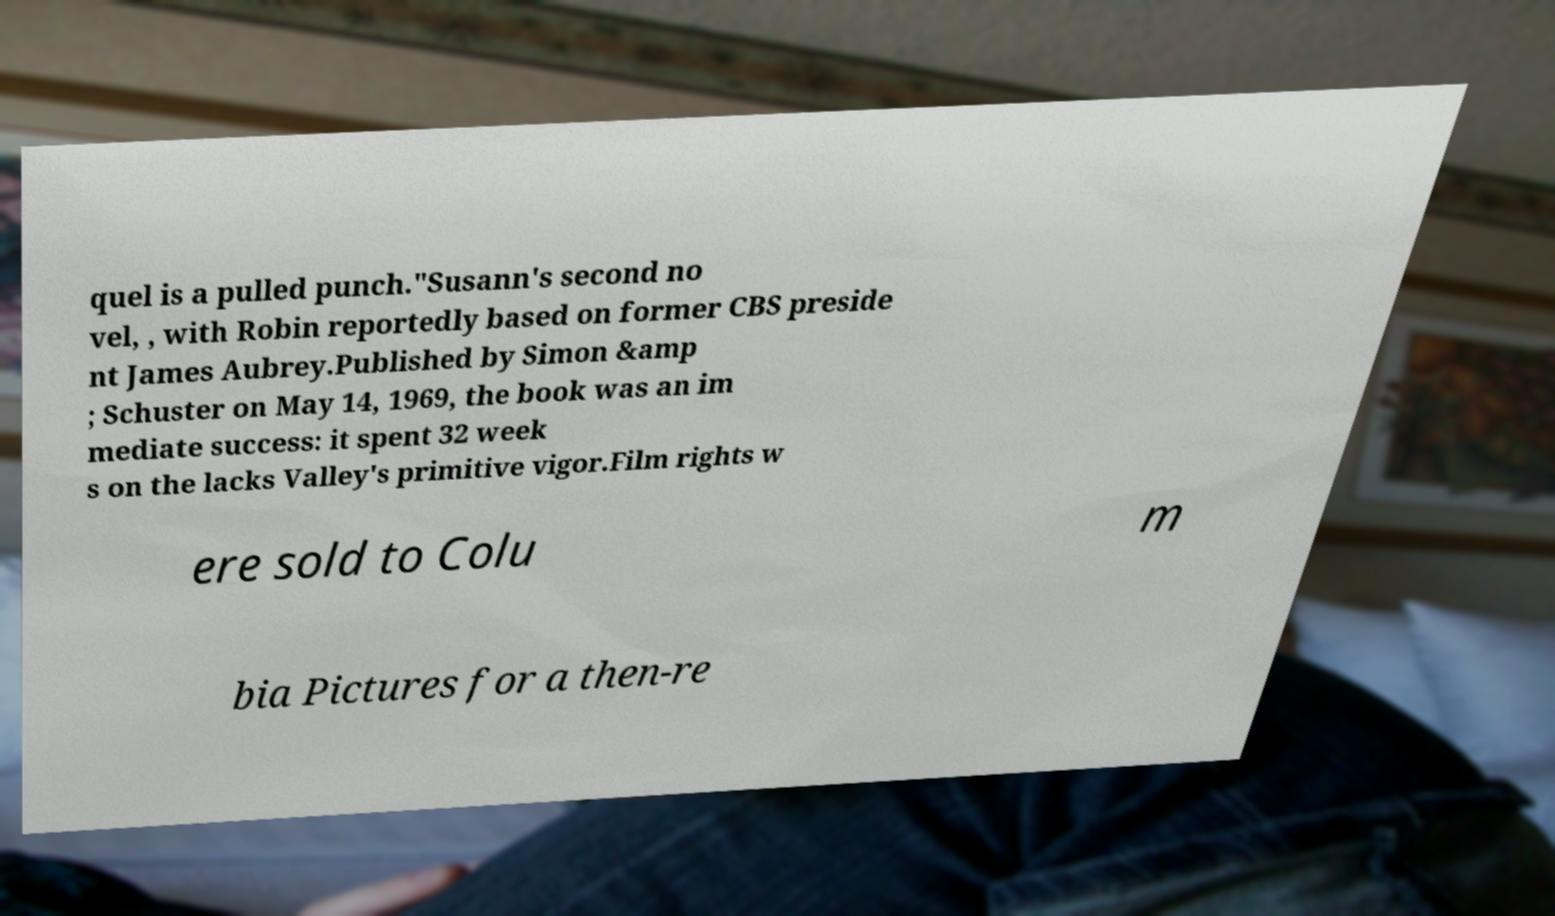Could you assist in decoding the text presented in this image and type it out clearly? quel is a pulled punch."Susann's second no vel, , with Robin reportedly based on former CBS preside nt James Aubrey.Published by Simon &amp ; Schuster on May 14, 1969, the book was an im mediate success: it spent 32 week s on the lacks Valley's primitive vigor.Film rights w ere sold to Colu m bia Pictures for a then-re 